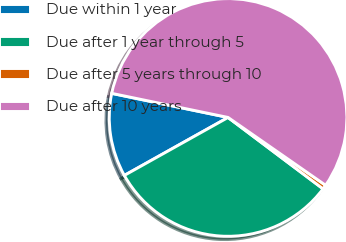Convert chart to OTSL. <chart><loc_0><loc_0><loc_500><loc_500><pie_chart><fcel>Due within 1 year<fcel>Due after 1 year through 5<fcel>Due after 5 years through 10<fcel>Due after 10 years<nl><fcel>11.36%<fcel>31.63%<fcel>0.59%<fcel>56.42%<nl></chart> 